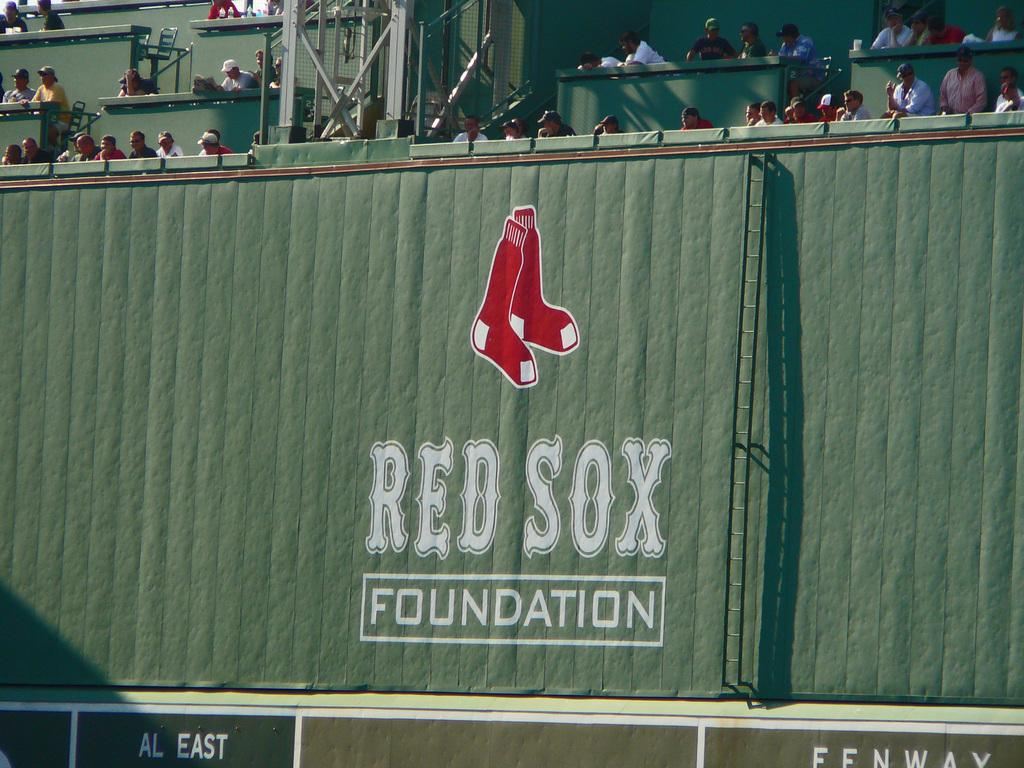Provide a one-sentence caption for the provided image. A wall that has a pair of red sox on it and says red sox foundation. 